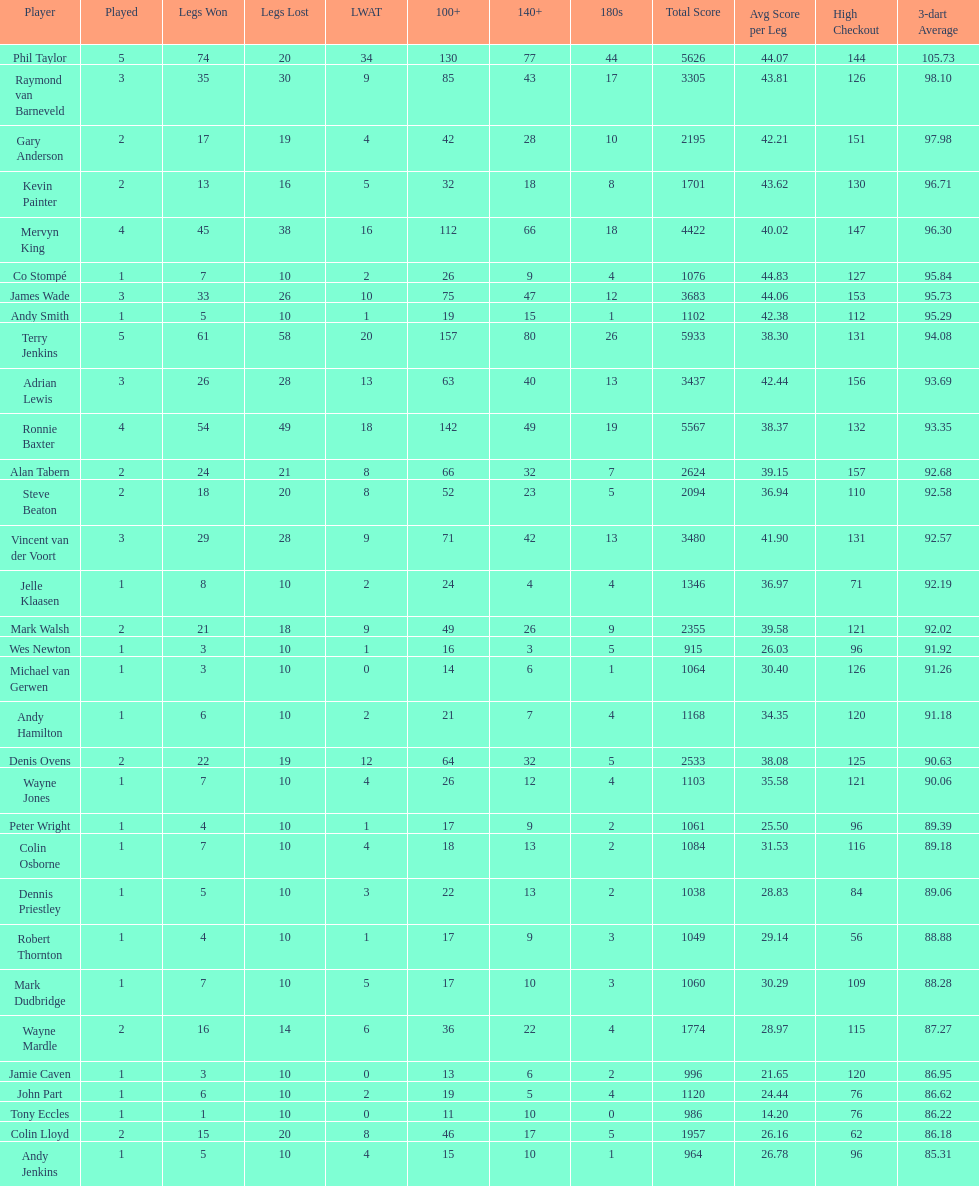Which player lost the least? Co Stompé, Andy Smith, Jelle Klaasen, Wes Newton, Michael van Gerwen, Andy Hamilton, Wayne Jones, Peter Wright, Colin Osborne, Dennis Priestley, Robert Thornton, Mark Dudbridge, Jamie Caven, John Part, Tony Eccles, Andy Jenkins. 